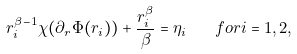Convert formula to latex. <formula><loc_0><loc_0><loc_500><loc_500>r _ { i } ^ { \beta - 1 } \chi ( \partial _ { r } \Phi ( r _ { i } ) ) + \frac { r _ { i } ^ { \beta } } { \beta } = \eta _ { i } \quad f o r i = 1 , 2 ,</formula> 